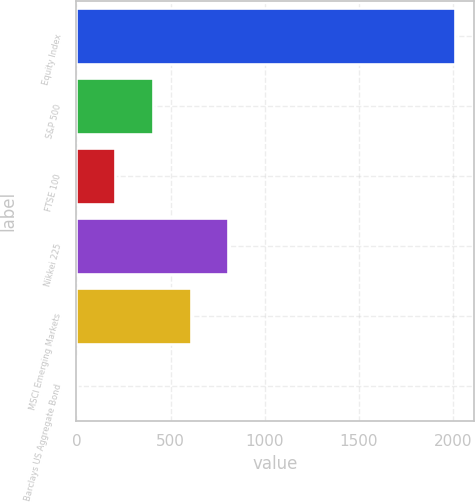Convert chart. <chart><loc_0><loc_0><loc_500><loc_500><bar_chart><fcel>Equity Index<fcel>S&P 500<fcel>FTSE 100<fcel>Nikkei 225<fcel>MSCI Emerging Markets<fcel>Barclays US Aggregate Bond<nl><fcel>2012<fcel>405.76<fcel>204.98<fcel>807.32<fcel>606.54<fcel>4.2<nl></chart> 